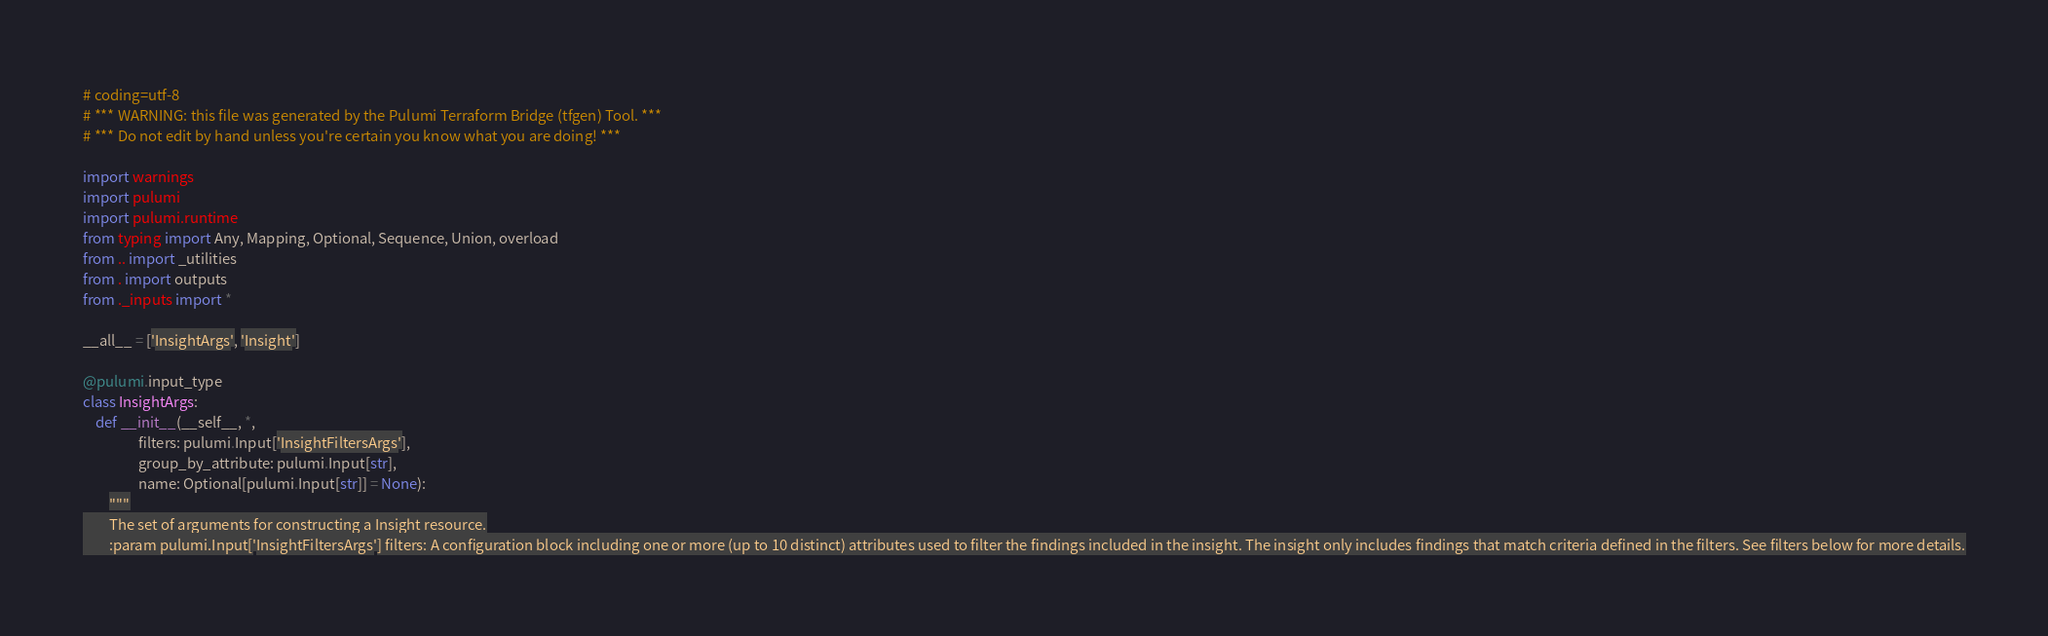<code> <loc_0><loc_0><loc_500><loc_500><_Python_># coding=utf-8
# *** WARNING: this file was generated by the Pulumi Terraform Bridge (tfgen) Tool. ***
# *** Do not edit by hand unless you're certain you know what you are doing! ***

import warnings
import pulumi
import pulumi.runtime
from typing import Any, Mapping, Optional, Sequence, Union, overload
from .. import _utilities
from . import outputs
from ._inputs import *

__all__ = ['InsightArgs', 'Insight']

@pulumi.input_type
class InsightArgs:
    def __init__(__self__, *,
                 filters: pulumi.Input['InsightFiltersArgs'],
                 group_by_attribute: pulumi.Input[str],
                 name: Optional[pulumi.Input[str]] = None):
        """
        The set of arguments for constructing a Insight resource.
        :param pulumi.Input['InsightFiltersArgs'] filters: A configuration block including one or more (up to 10 distinct) attributes used to filter the findings included in the insight. The insight only includes findings that match criteria defined in the filters. See filters below for more details.</code> 